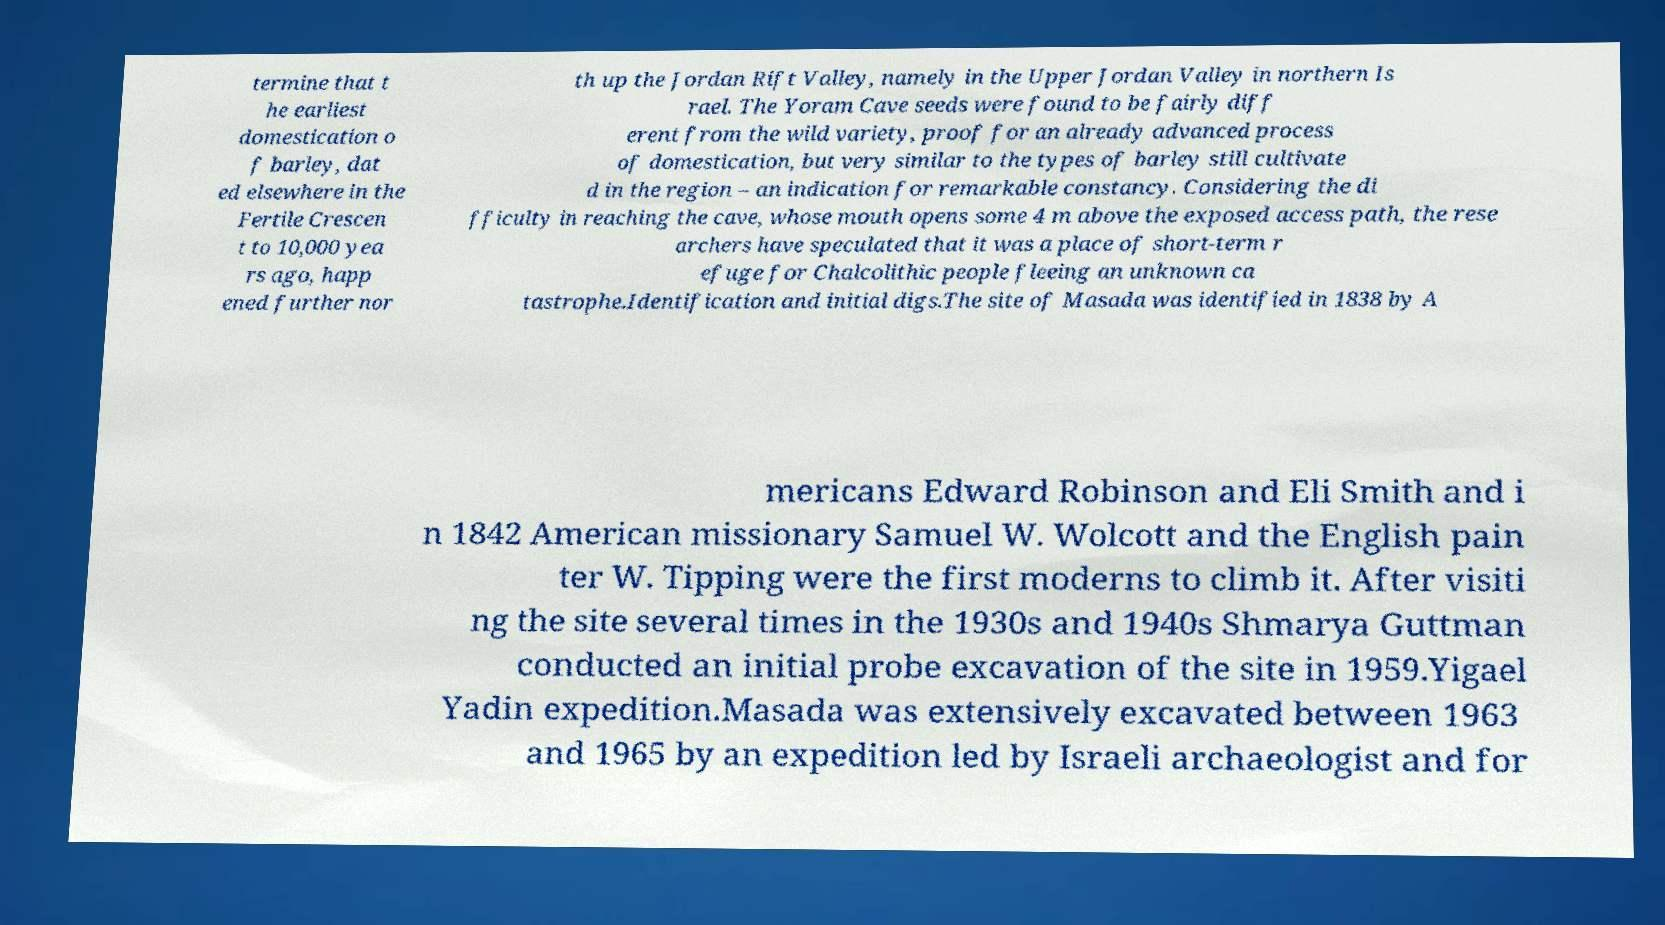Please identify and transcribe the text found in this image. termine that t he earliest domestication o f barley, dat ed elsewhere in the Fertile Crescen t to 10,000 yea rs ago, happ ened further nor th up the Jordan Rift Valley, namely in the Upper Jordan Valley in northern Is rael. The Yoram Cave seeds were found to be fairly diff erent from the wild variety, proof for an already advanced process of domestication, but very similar to the types of barley still cultivate d in the region – an indication for remarkable constancy. Considering the di fficulty in reaching the cave, whose mouth opens some 4 m above the exposed access path, the rese archers have speculated that it was a place of short-term r efuge for Chalcolithic people fleeing an unknown ca tastrophe.Identification and initial digs.The site of Masada was identified in 1838 by A mericans Edward Robinson and Eli Smith and i n 1842 American missionary Samuel W. Wolcott and the English pain ter W. Tipping were the first moderns to climb it. After visiti ng the site several times in the 1930s and 1940s Shmarya Guttman conducted an initial probe excavation of the site in 1959.Yigael Yadin expedition.Masada was extensively excavated between 1963 and 1965 by an expedition led by Israeli archaeologist and for 